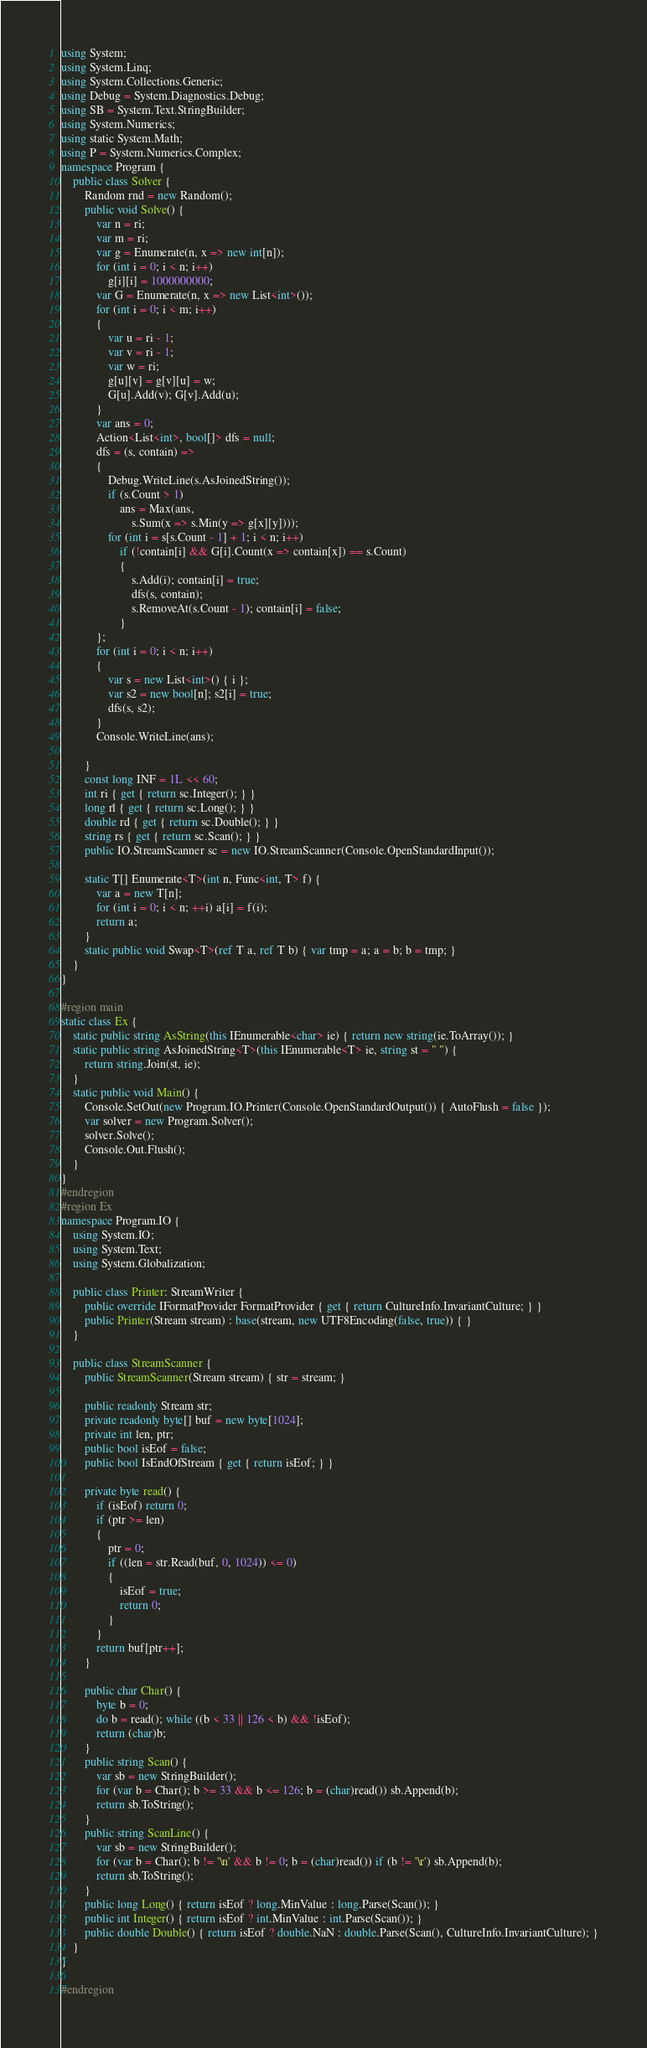<code> <loc_0><loc_0><loc_500><loc_500><_C#_>using System;
using System.Linq;
using System.Collections.Generic;
using Debug = System.Diagnostics.Debug;
using SB = System.Text.StringBuilder;
using System.Numerics;
using static System.Math;
using P = System.Numerics.Complex;
namespace Program {
    public class Solver {
        Random rnd = new Random();
        public void Solve() {
            var n = ri;
            var m = ri;
            var g = Enumerate(n, x => new int[n]);
            for (int i = 0; i < n; i++)
                g[i][i] = 1000000000;
            var G = Enumerate(n, x => new List<int>());
            for (int i = 0; i < m; i++)
            {
                var u = ri - 1;
                var v = ri - 1;
                var w = ri;
                g[u][v] = g[v][u] = w;
                G[u].Add(v); G[v].Add(u);
            }
            var ans = 0;
            Action<List<int>, bool[]> dfs = null;
            dfs = (s, contain) =>
            {
                Debug.WriteLine(s.AsJoinedString());
                if (s.Count > 1)
                    ans = Max(ans,
                        s.Sum(x => s.Min(y => g[x][y])));
                for (int i = s[s.Count - 1] + 1; i < n; i++)
                    if (!contain[i] && G[i].Count(x => contain[x]) == s.Count)
                    {
                        s.Add(i); contain[i] = true;
                        dfs(s, contain);
                        s.RemoveAt(s.Count - 1); contain[i] = false;
                    }
            };
            for (int i = 0; i < n; i++)
            {
                var s = new List<int>() { i };
                var s2 = new bool[n]; s2[i] = true;
                dfs(s, s2);
            }
            Console.WriteLine(ans);

        }
        const long INF = 1L << 60;
        int ri { get { return sc.Integer(); } }
        long rl { get { return sc.Long(); } }
        double rd { get { return sc.Double(); } }
        string rs { get { return sc.Scan(); } }
        public IO.StreamScanner sc = new IO.StreamScanner(Console.OpenStandardInput());

        static T[] Enumerate<T>(int n, Func<int, T> f) {
            var a = new T[n];
            for (int i = 0; i < n; ++i) a[i] = f(i);
            return a;
        }
        static public void Swap<T>(ref T a, ref T b) { var tmp = a; a = b; b = tmp; }
    }
}

#region main
static class Ex {
    static public string AsString(this IEnumerable<char> ie) { return new string(ie.ToArray()); }
    static public string AsJoinedString<T>(this IEnumerable<T> ie, string st = " ") {
        return string.Join(st, ie);
    }
    static public void Main() {
        Console.SetOut(new Program.IO.Printer(Console.OpenStandardOutput()) { AutoFlush = false });
        var solver = new Program.Solver();
        solver.Solve();
        Console.Out.Flush();
    }
}
#endregion
#region Ex
namespace Program.IO {
    using System.IO;
    using System.Text;
    using System.Globalization;

    public class Printer: StreamWriter {
        public override IFormatProvider FormatProvider { get { return CultureInfo.InvariantCulture; } }
        public Printer(Stream stream) : base(stream, new UTF8Encoding(false, true)) { }
    }

    public class StreamScanner {
        public StreamScanner(Stream stream) { str = stream; }

        public readonly Stream str;
        private readonly byte[] buf = new byte[1024];
        private int len, ptr;
        public bool isEof = false;
        public bool IsEndOfStream { get { return isEof; } }

        private byte read() {
            if (isEof) return 0;
            if (ptr >= len)
            {
                ptr = 0;
                if ((len = str.Read(buf, 0, 1024)) <= 0)
                {
                    isEof = true;
                    return 0;
                }
            }
            return buf[ptr++];
        }

        public char Char() {
            byte b = 0;
            do b = read(); while ((b < 33 || 126 < b) && !isEof);
            return (char)b;
        }
        public string Scan() {
            var sb = new StringBuilder();
            for (var b = Char(); b >= 33 && b <= 126; b = (char)read()) sb.Append(b);
            return sb.ToString();
        }
        public string ScanLine() {
            var sb = new StringBuilder();
            for (var b = Char(); b != '\n' && b != 0; b = (char)read()) if (b != '\r') sb.Append(b);
            return sb.ToString();
        }
        public long Long() { return isEof ? long.MinValue : long.Parse(Scan()); }
        public int Integer() { return isEof ? int.MinValue : int.Parse(Scan()); }
        public double Double() { return isEof ? double.NaN : double.Parse(Scan(), CultureInfo.InvariantCulture); }
    }
}

#endregion
</code> 